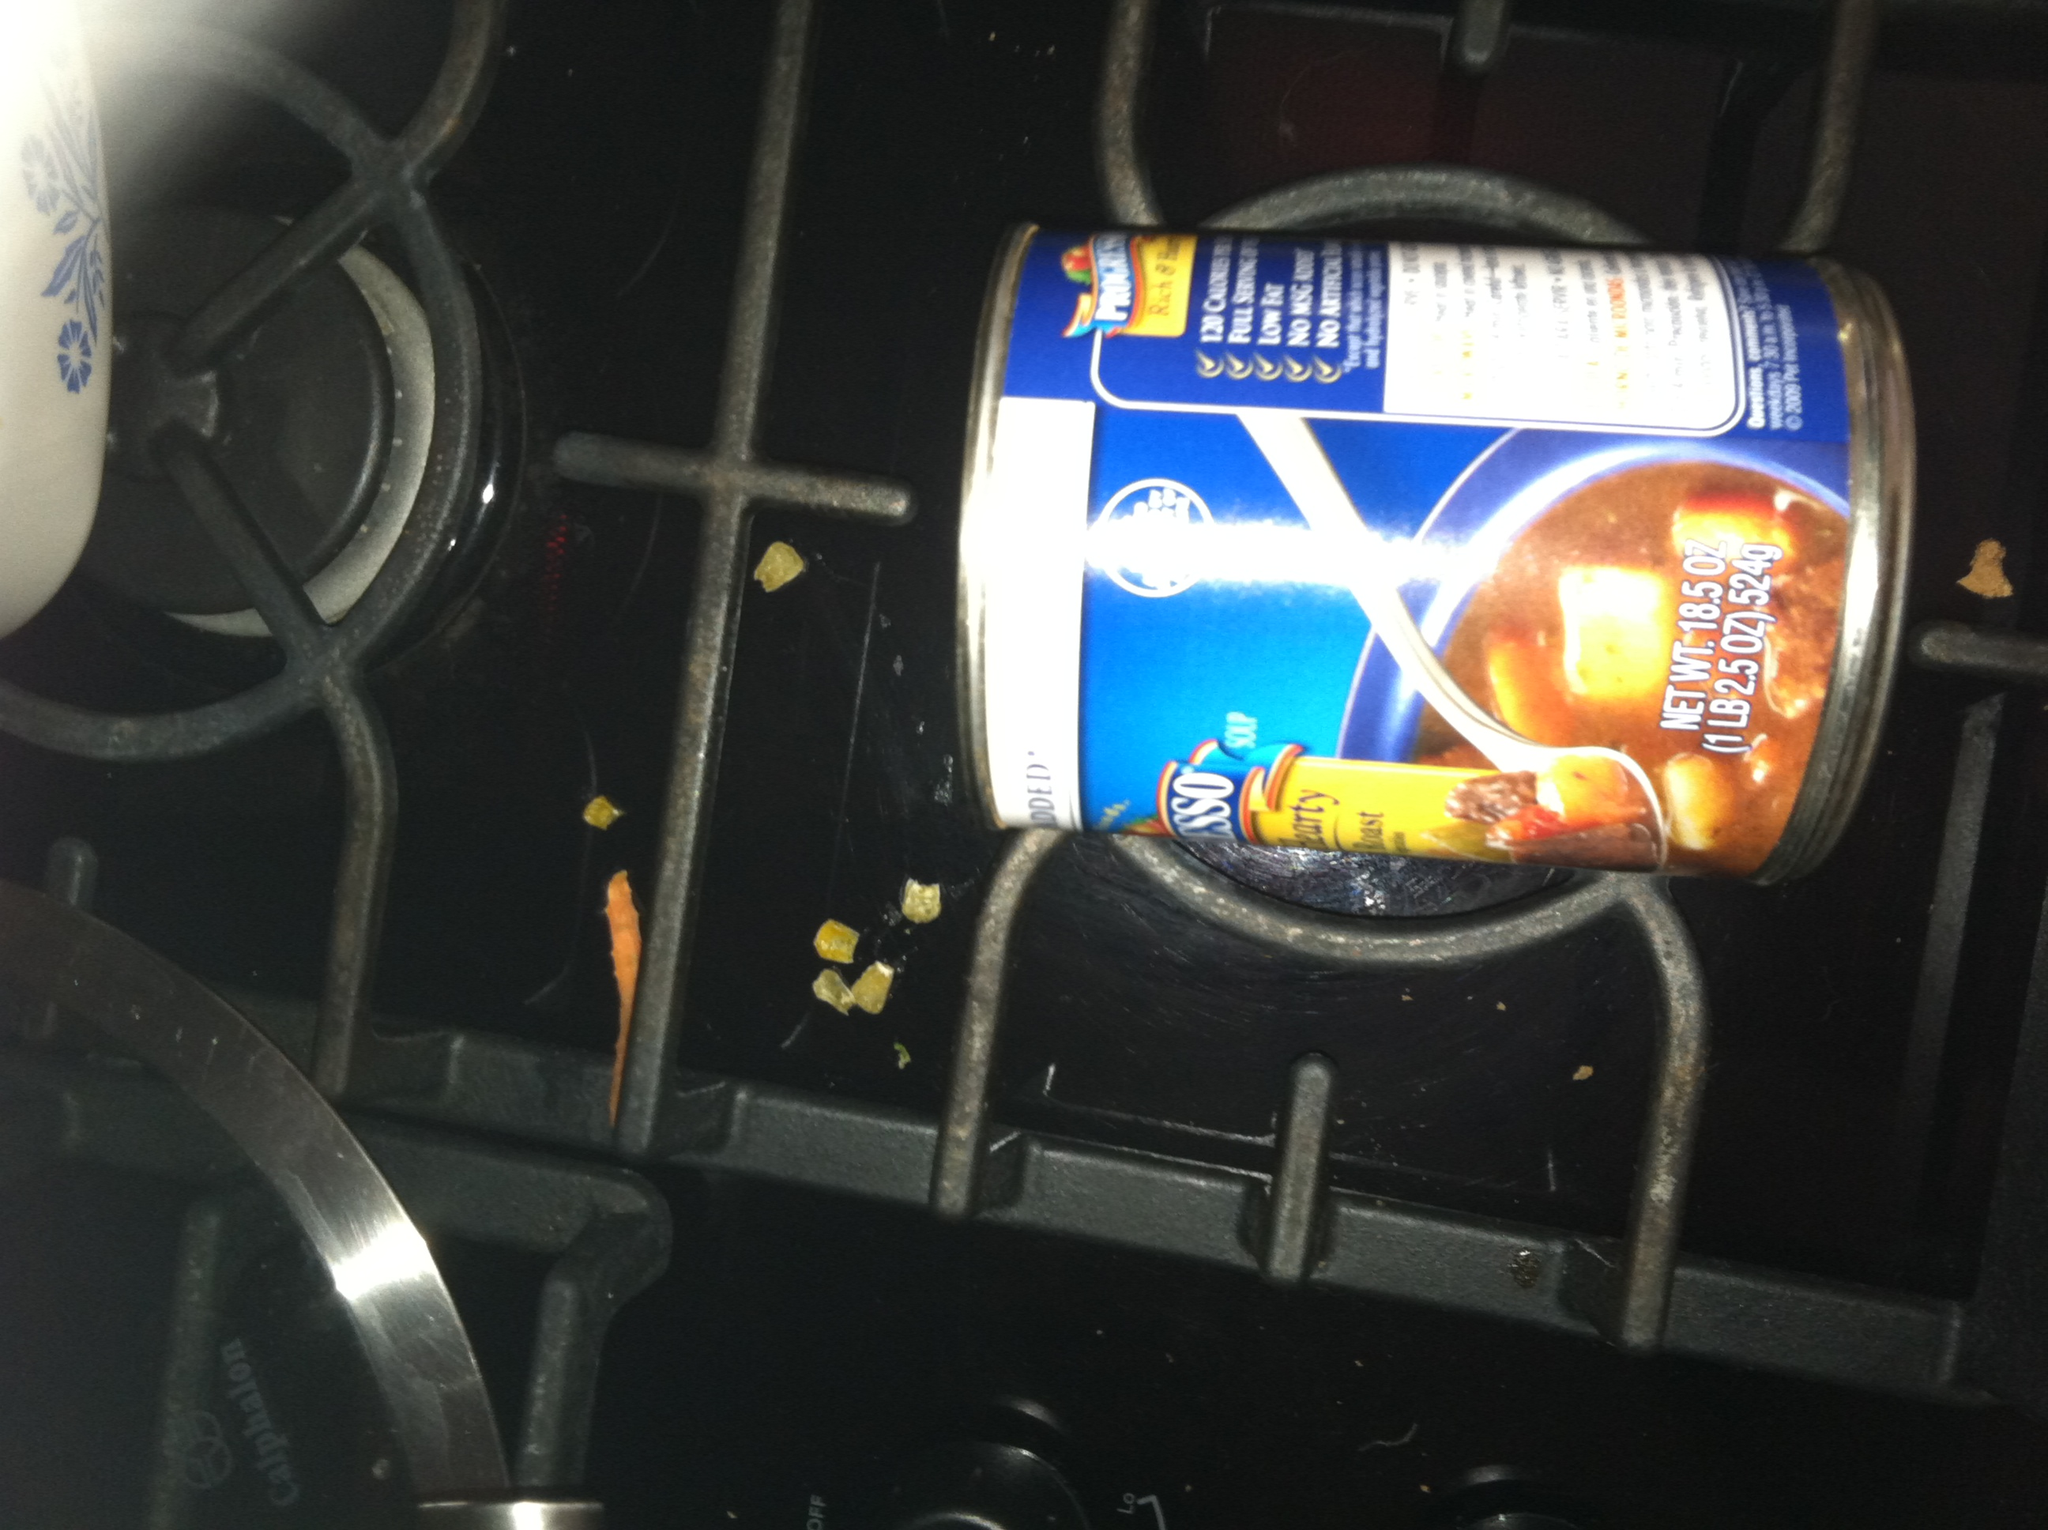If you could turn this can of soup into anything else, what would it be and why? If I could transform this can of soup into anything else, I would turn it into a magical potion that grants the drinker the ability to travel through time. This potion would enable those who consume it to explore different eras, from ancient civilizations to future societies, gaining knowledge and wisdom from various points in history. This transformation would provide endless opportunities for adventures, learning experiences, and a deeper understanding of how human societies have evolved over the ages. 